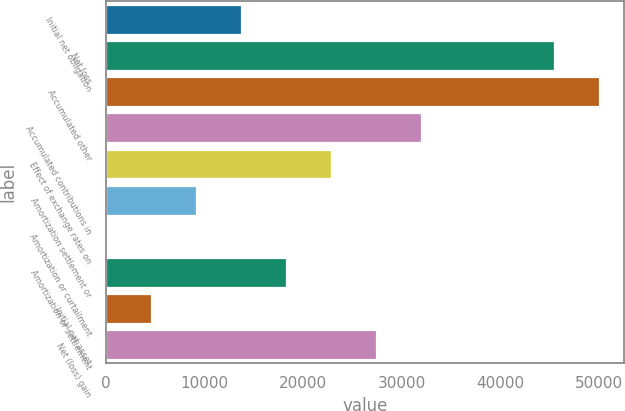Convert chart to OTSL. <chart><loc_0><loc_0><loc_500><loc_500><bar_chart><fcel>Initial net obligation<fcel>Net loss<fcel>Accumulated other<fcel>Accumulated contributions in<fcel>Effect of exchange rates on<fcel>Amortization settlement or<fcel>Amortization or curtailment<fcel>Amortization or settlement<fcel>Initial net asset<fcel>Net (loss) gain<nl><fcel>13682.2<fcel>45467<fcel>50027.4<fcel>31923.8<fcel>22803<fcel>9121.8<fcel>1<fcel>18242.6<fcel>4561.4<fcel>27363.4<nl></chart> 